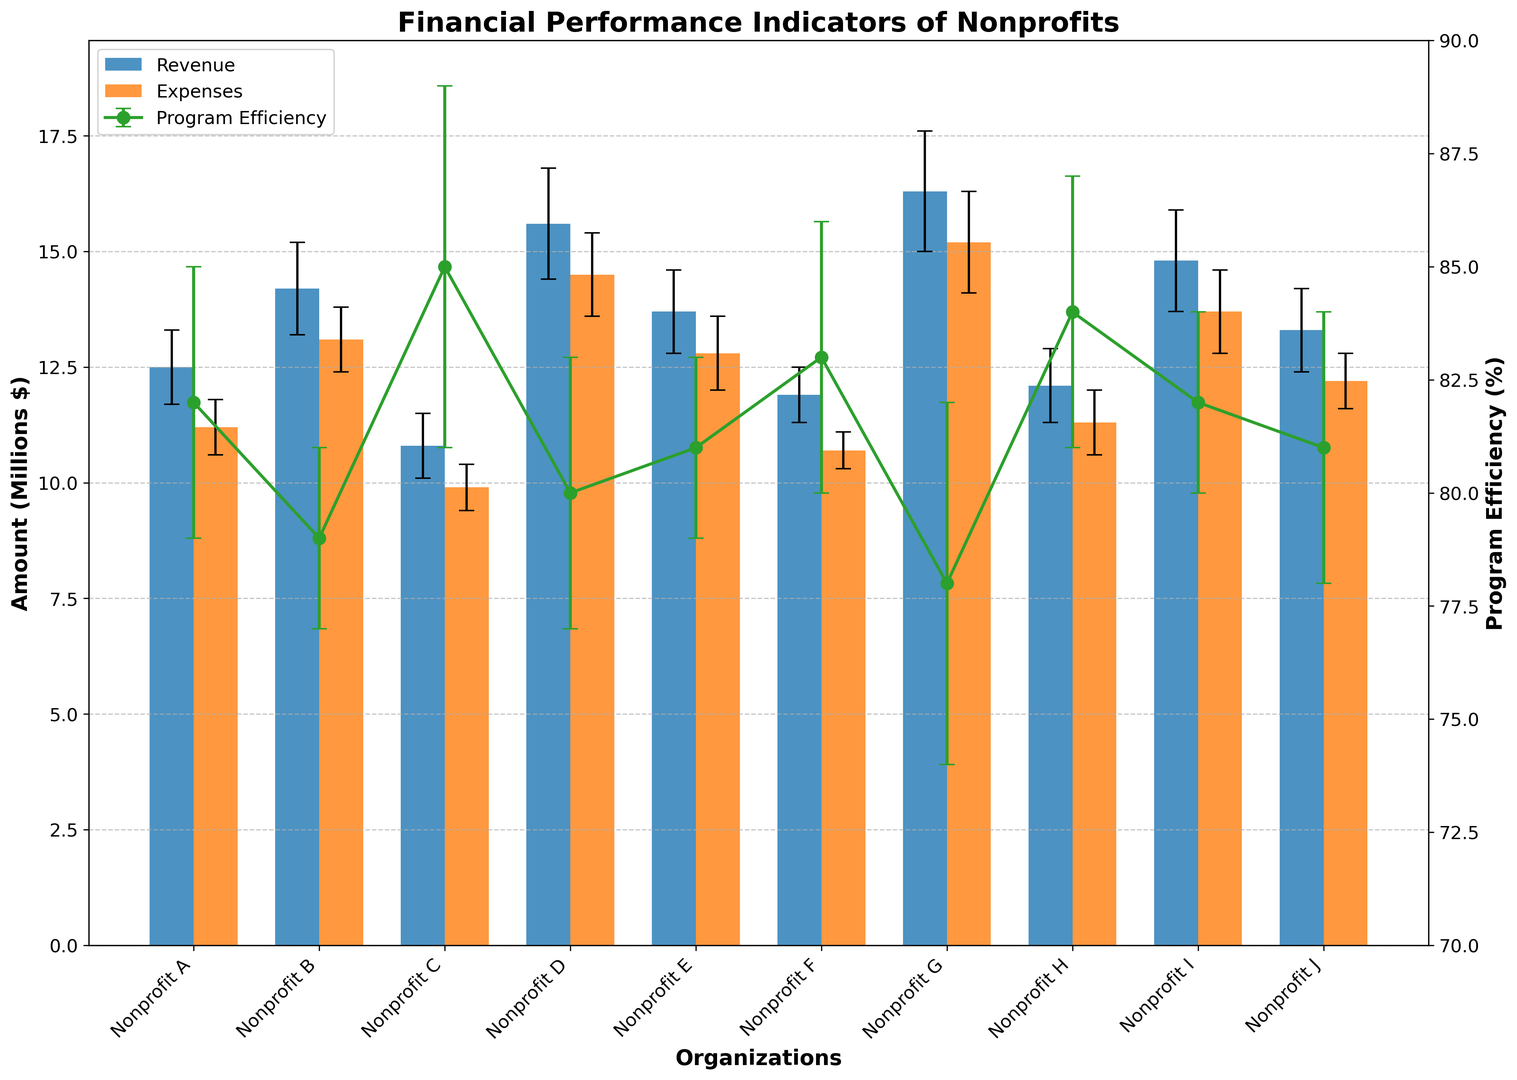Which organization has the highest revenue? By looking at the height of the blue bars representing revenue, Nonprofit G has the highest one.
Answer: Nonprofit G Which organization has the highest program efficiency percentage? By observing the green line representing program efficiency, it’s clear the tallest point corresponds to Nonprofit C.
Answer: Nonprofit C How does the revenue of Nonprofit A compare to its expenses? Nonprofit A's blue bar (revenue) is slightly taller than its orange bar (expenses), indicating higher revenue than expenses.
Answer: Higher revenue than expenses Which organizations have higher expenses than revenue? By comparing the heights of blue and orange bars, Nonprofits B, D, and G have taller orange bars than blue, indicating higher expenses.
Answer: Nonprofits B, D, G What is the average revenue of the nonprofits? Add all the revenue values (12.5, 14.2, 10.8, 15.6, 13.7, 11.9, 16.3, 12.1, 14.8, 13.3) then divide by the number of organizations, which is 10. Calculation: (12.5 + 14.2 + 10.8 + 15.6 + 13.7 + 11.9 + 16.3 + 12.1 + 14.8 + 13.3) / 10 = 135.2 / 10 = 13.52.
Answer: 13.52 million Which organization has the lowest program efficiency percentage? By checking the green line and finding the lowest point, Nonprofit G has the lowest program efficiency percentage.
Answer: Nonprofit G What is the sum of the expenses for Nonprofit C and Nonprofit E? Add the expenses values of Nonprofit C and E: 9.9 + 12.8 = 22.7
Answer: 22.7 million Which organization has the smallest error margin in expenses? By comparing the black error bars on the orange bars, the smallest error bar corresponds to Nonprofit F.
Answer: Nonprofit F What is the difference between the maximum and minimum program efficiency percentages? The maximum program efficiency is 85% (Nonprofit C), and the minimum is 78% (Nonprofit G). So the difference is 85 - 78 = 7%.
Answer: 7% Which organizations have the same program efficiency percentage? By examining the green points, Nonprofits A and I both have a program efficiency of 82%, and Nonprofits E and J both have a program efficiency of 81%.
Answer: Nonprofits A, I and Nonprofits E, J 